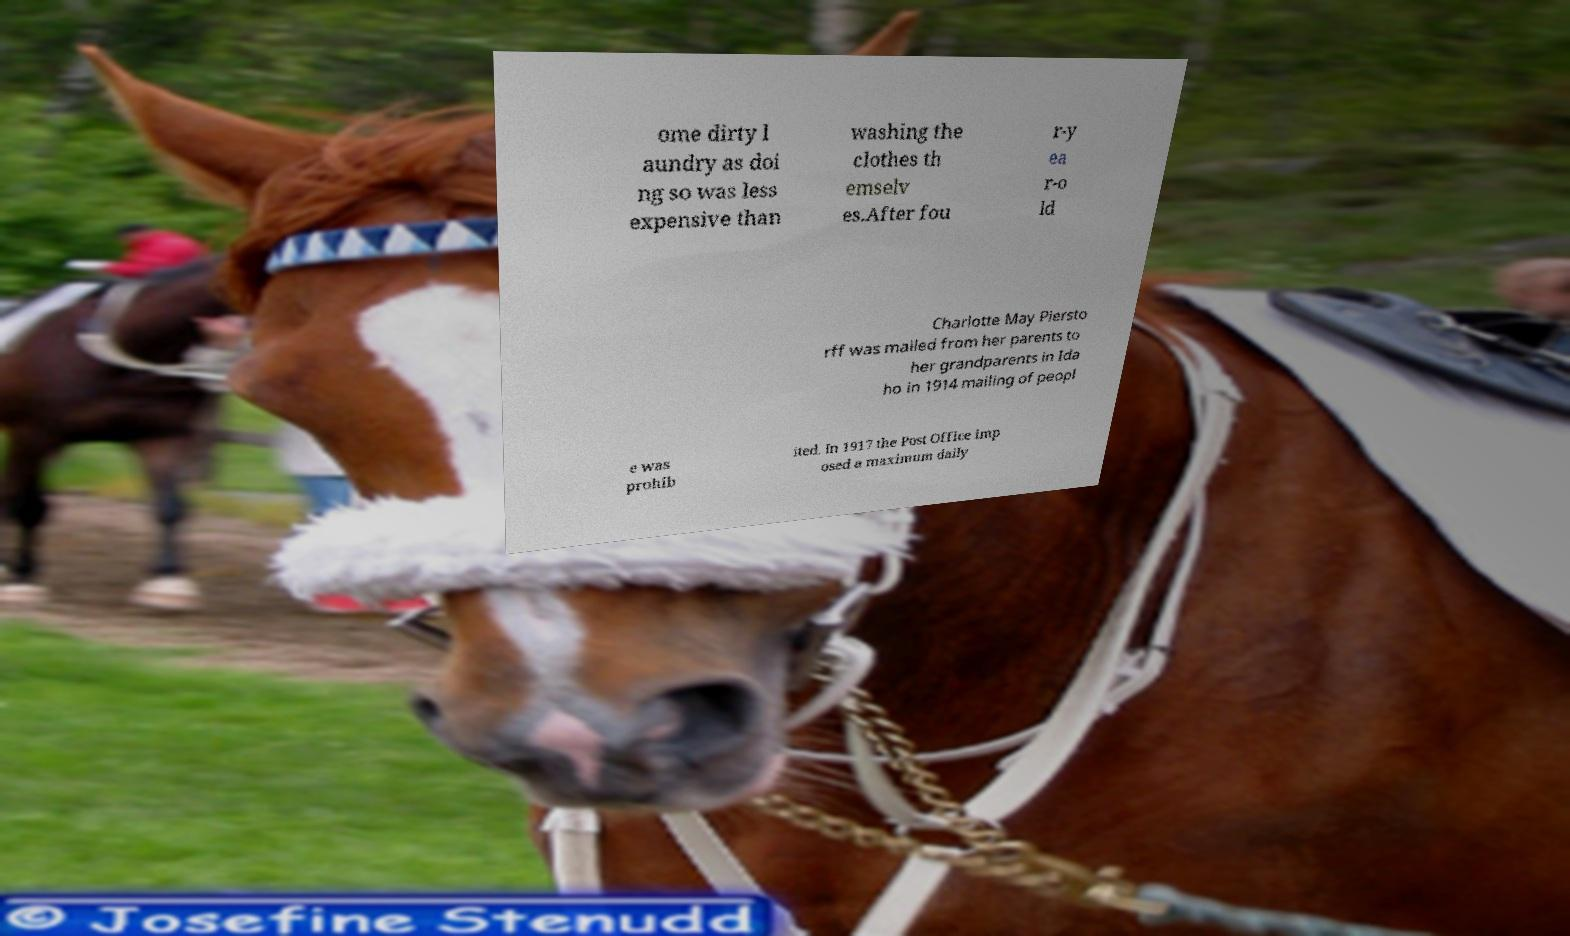Could you assist in decoding the text presented in this image and type it out clearly? ome dirty l aundry as doi ng so was less expensive than washing the clothes th emselv es.After fou r-y ea r-o ld Charlotte May Piersto rff was mailed from her parents to her grandparents in Ida ho in 1914 mailing of peopl e was prohib ited. In 1917 the Post Office imp osed a maximum daily 